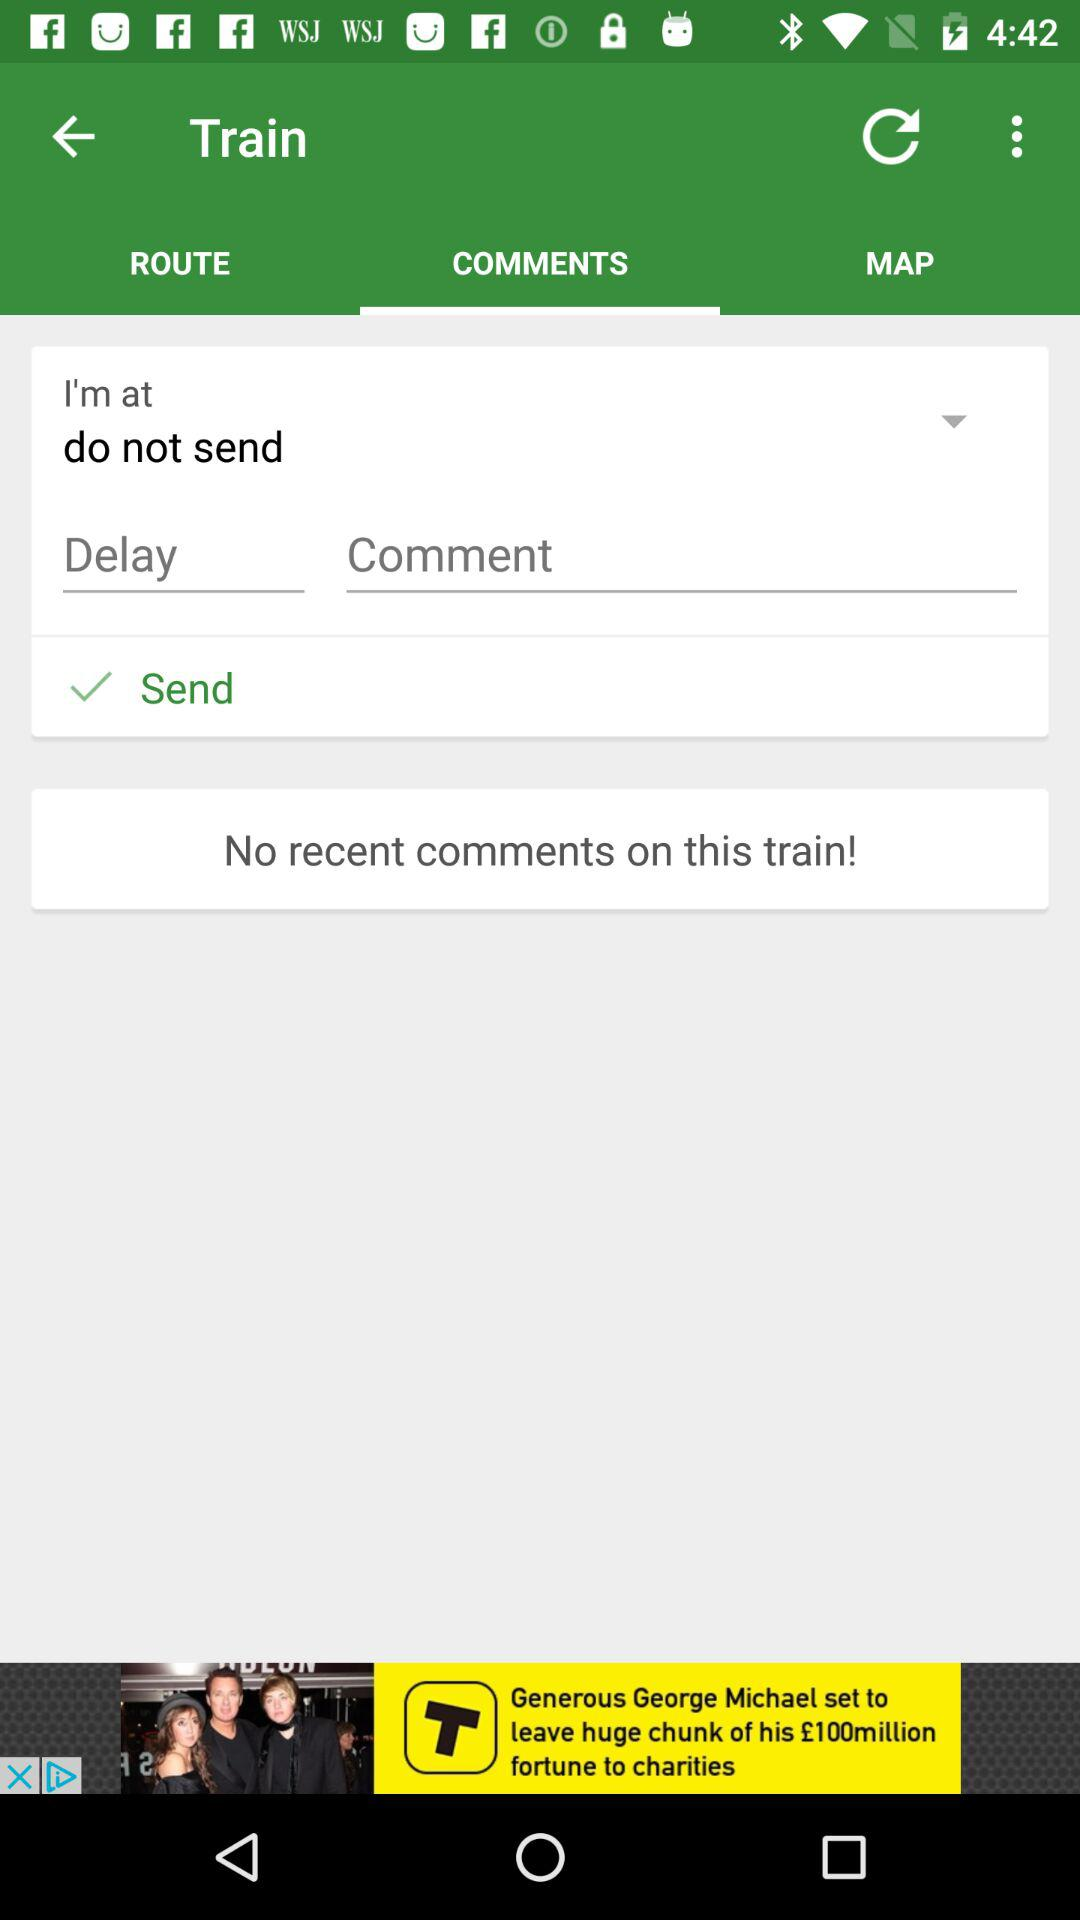Which train routes are available?
When the provided information is insufficient, respond with <no answer>. <no answer> 